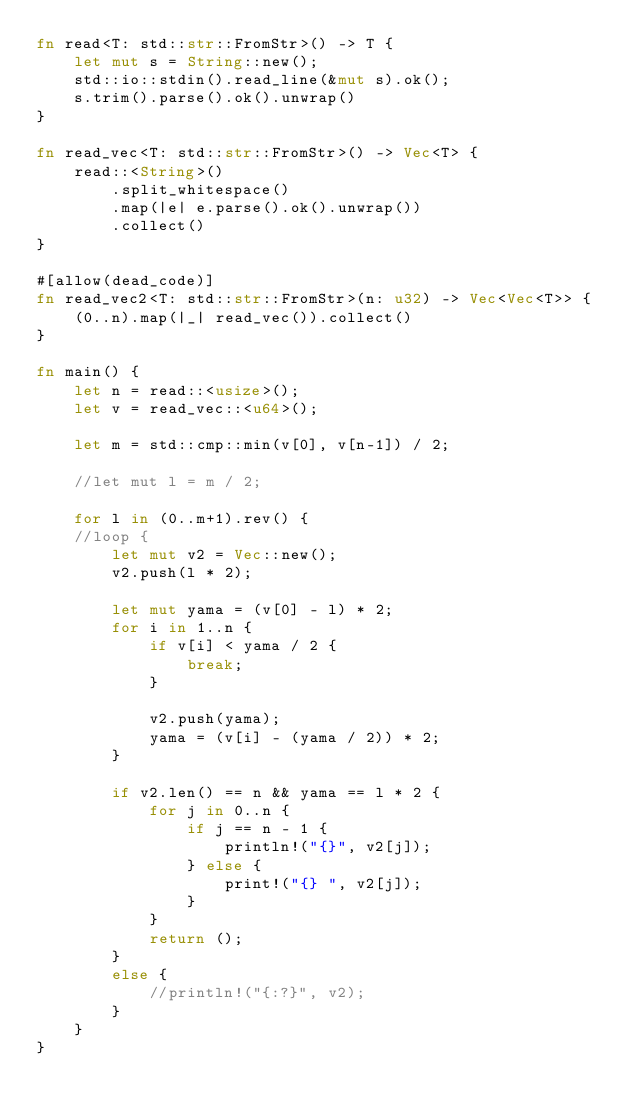<code> <loc_0><loc_0><loc_500><loc_500><_Rust_>fn read<T: std::str::FromStr>() -> T {
    let mut s = String::new();
    std::io::stdin().read_line(&mut s).ok();
    s.trim().parse().ok().unwrap()
}

fn read_vec<T: std::str::FromStr>() -> Vec<T> {
    read::<String>()
        .split_whitespace()
        .map(|e| e.parse().ok().unwrap())
        .collect()
}

#[allow(dead_code)]
fn read_vec2<T: std::str::FromStr>(n: u32) -> Vec<Vec<T>> {
    (0..n).map(|_| read_vec()).collect()
}

fn main() {
    let n = read::<usize>();
    let v = read_vec::<u64>();

    let m = std::cmp::min(v[0], v[n-1]) / 2;

    //let mut l = m / 2;

    for l in (0..m+1).rev() {
    //loop {
        let mut v2 = Vec::new();
        v2.push(l * 2);

        let mut yama = (v[0] - l) * 2;
        for i in 1..n {
            if v[i] < yama / 2 {
                break;
            }

            v2.push(yama);
            yama = (v[i] - (yama / 2)) * 2;
        }

        if v2.len() == n && yama == l * 2 {
            for j in 0..n {
                if j == n - 1 {
                    println!("{}", v2[j]);
                } else {
                    print!("{} ", v2[j]);
                }
            }
            return ();
        }
        else {
            //println!("{:?}", v2);
        }
    }
}
</code> 